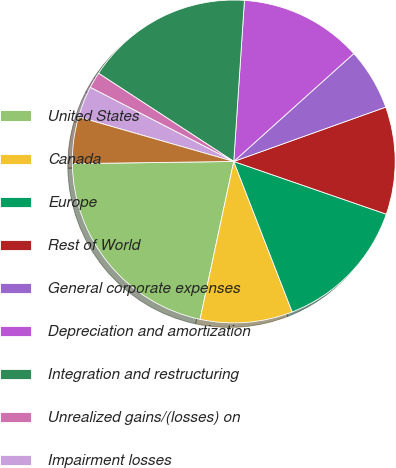Convert chart to OTSL. <chart><loc_0><loc_0><loc_500><loc_500><pie_chart><fcel>United States<fcel>Canada<fcel>Europe<fcel>Rest of World<fcel>General corporate expenses<fcel>Depreciation and amortization<fcel>Integration and restructuring<fcel>Unrealized gains/(losses) on<fcel>Impairment losses<fcel>Equity award compensation<nl><fcel>21.44%<fcel>9.24%<fcel>13.81%<fcel>10.76%<fcel>6.19%<fcel>12.29%<fcel>16.86%<fcel>1.61%<fcel>3.14%<fcel>4.66%<nl></chart> 